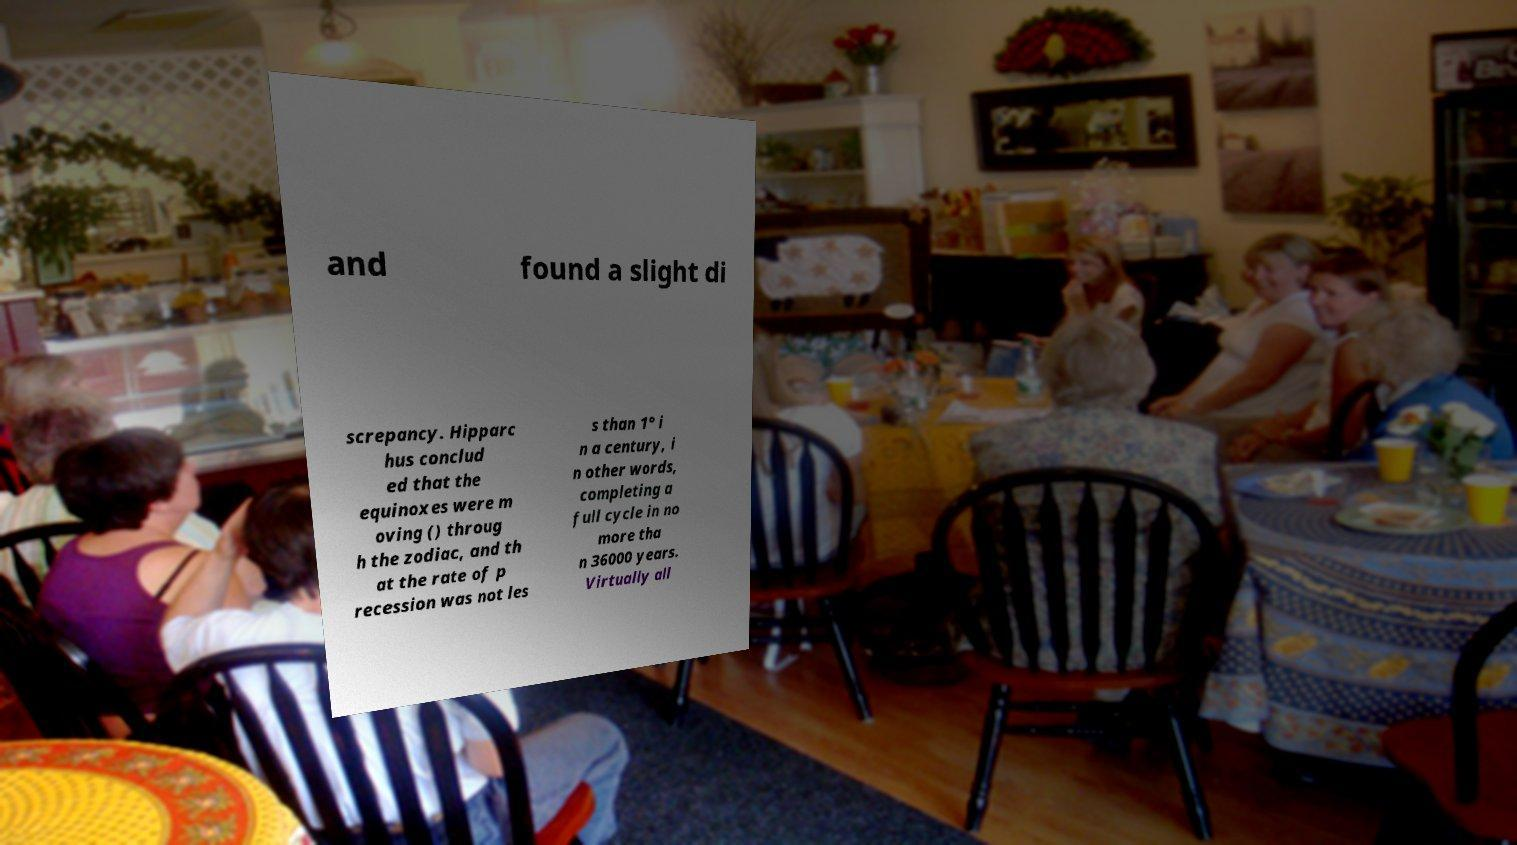Can you read and provide the text displayed in the image?This photo seems to have some interesting text. Can you extract and type it out for me? and found a slight di screpancy. Hipparc hus conclud ed that the equinoxes were m oving () throug h the zodiac, and th at the rate of p recession was not les s than 1° i n a century, i n other words, completing a full cycle in no more tha n 36000 years. Virtually all 